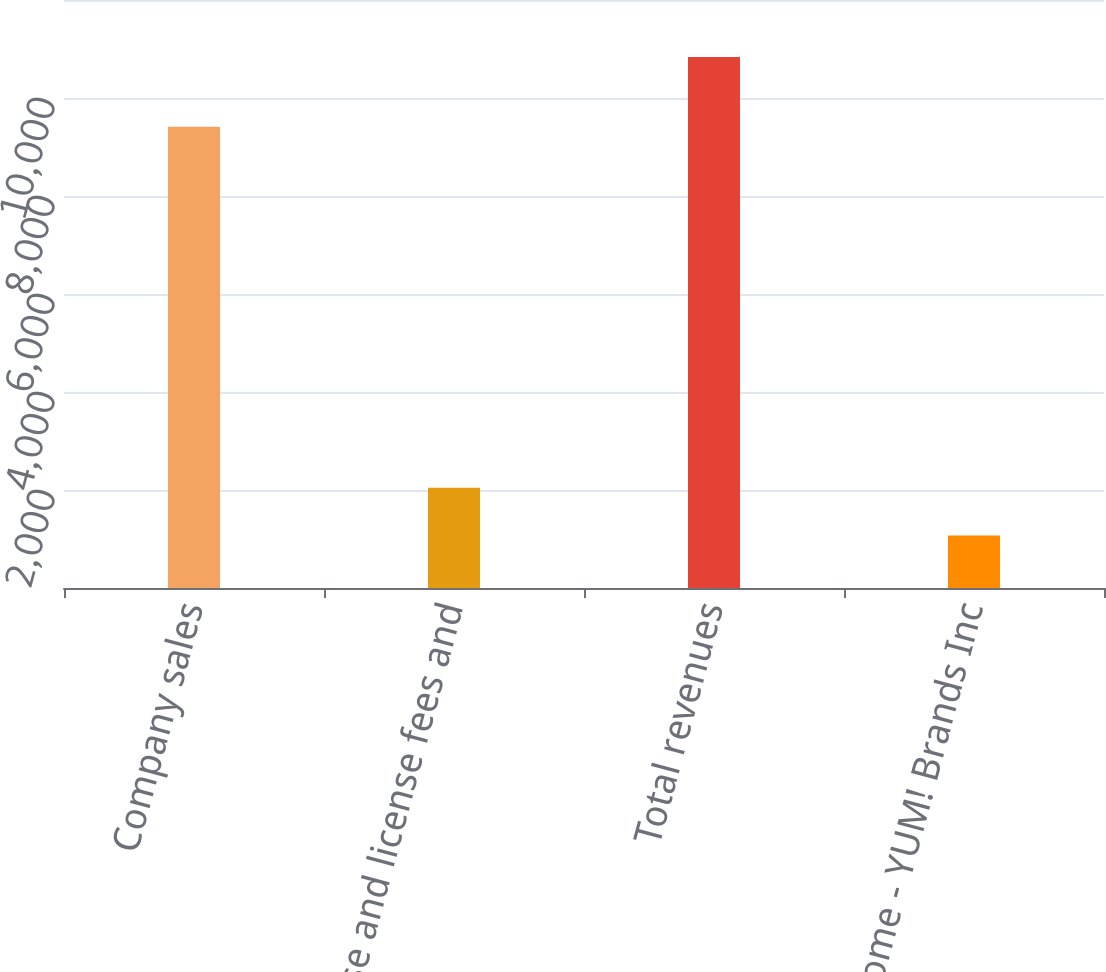Convert chart. <chart><loc_0><loc_0><loc_500><loc_500><bar_chart><fcel>Company sales<fcel>Franchise and license fees and<fcel>Total revenues<fcel>Net Income - YUM! Brands Inc<nl><fcel>9413<fcel>2047.5<fcel>10836<fcel>1071<nl></chart> 